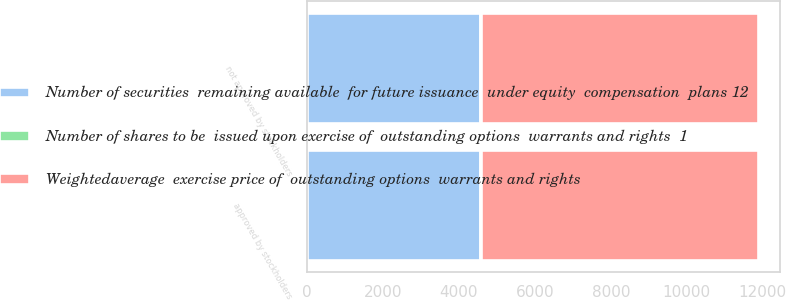<chart> <loc_0><loc_0><loc_500><loc_500><stacked_bar_chart><ecel><fcel>approved by stockholders<fcel>not approved by stockholders<nl><fcel>Weightedaverage  exercise price of  outstanding options  warrants and rights<fcel>7269<fcel>7269<nl><fcel>Number of shares to be  issued upon exercise of  outstanding options  warrants and rights  1<fcel>29.31<fcel>29.31<nl><fcel>Number of securities  remaining available  for future issuance  under equity  compensation  plans 12<fcel>4565<fcel>4565<nl></chart> 